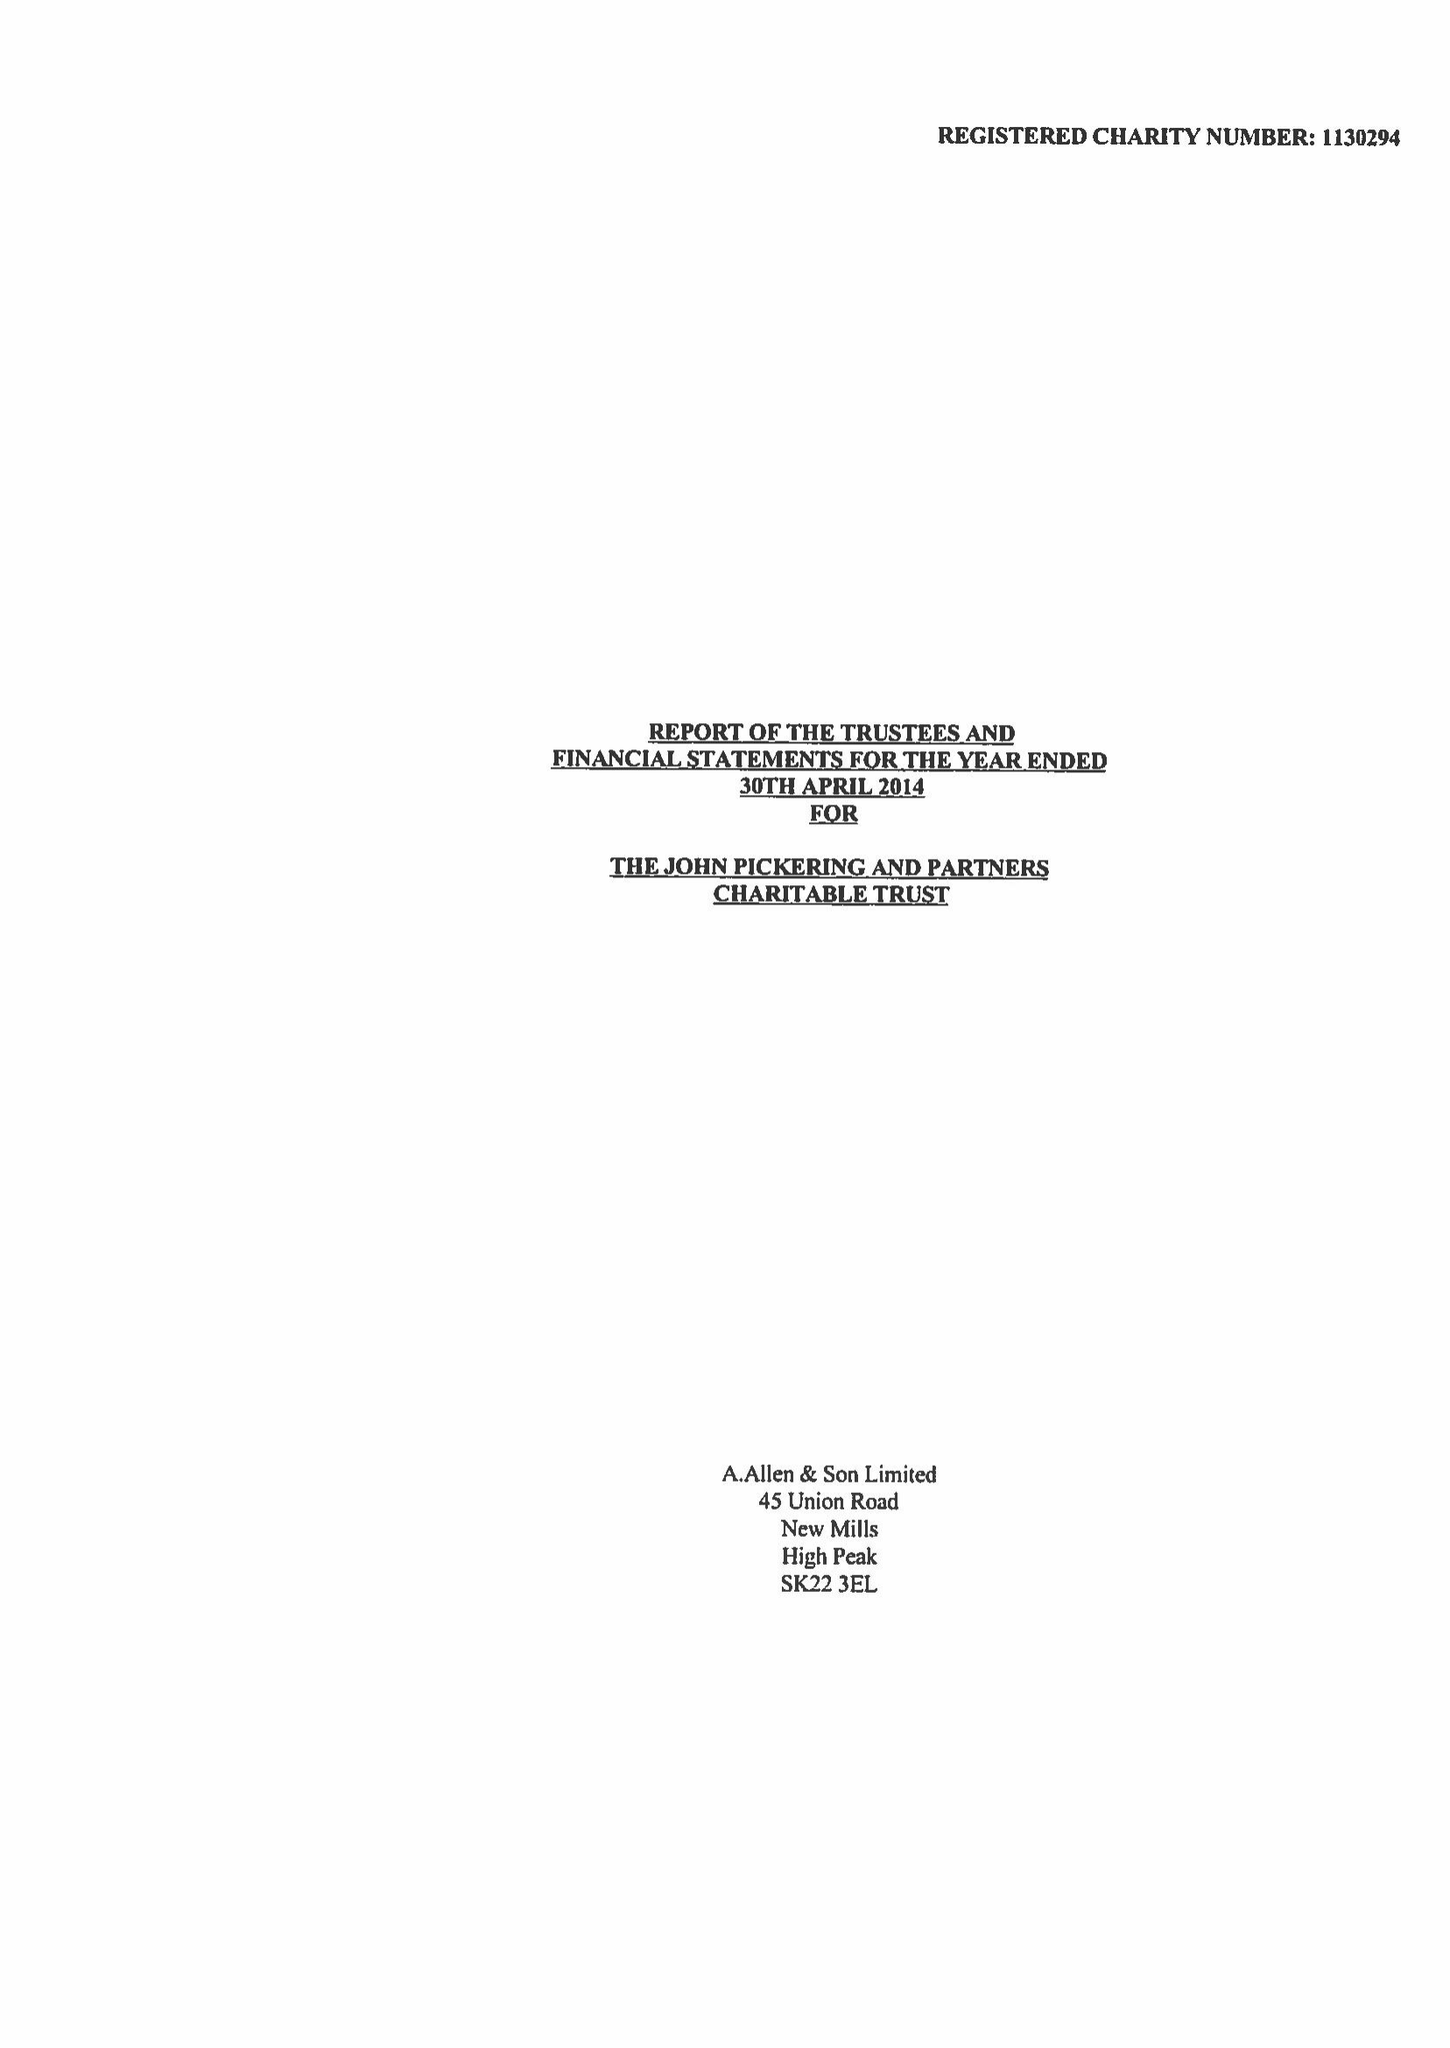What is the value for the charity_name?
Answer the question using a single word or phrase. John Pickering and Partners Charitable Trust 